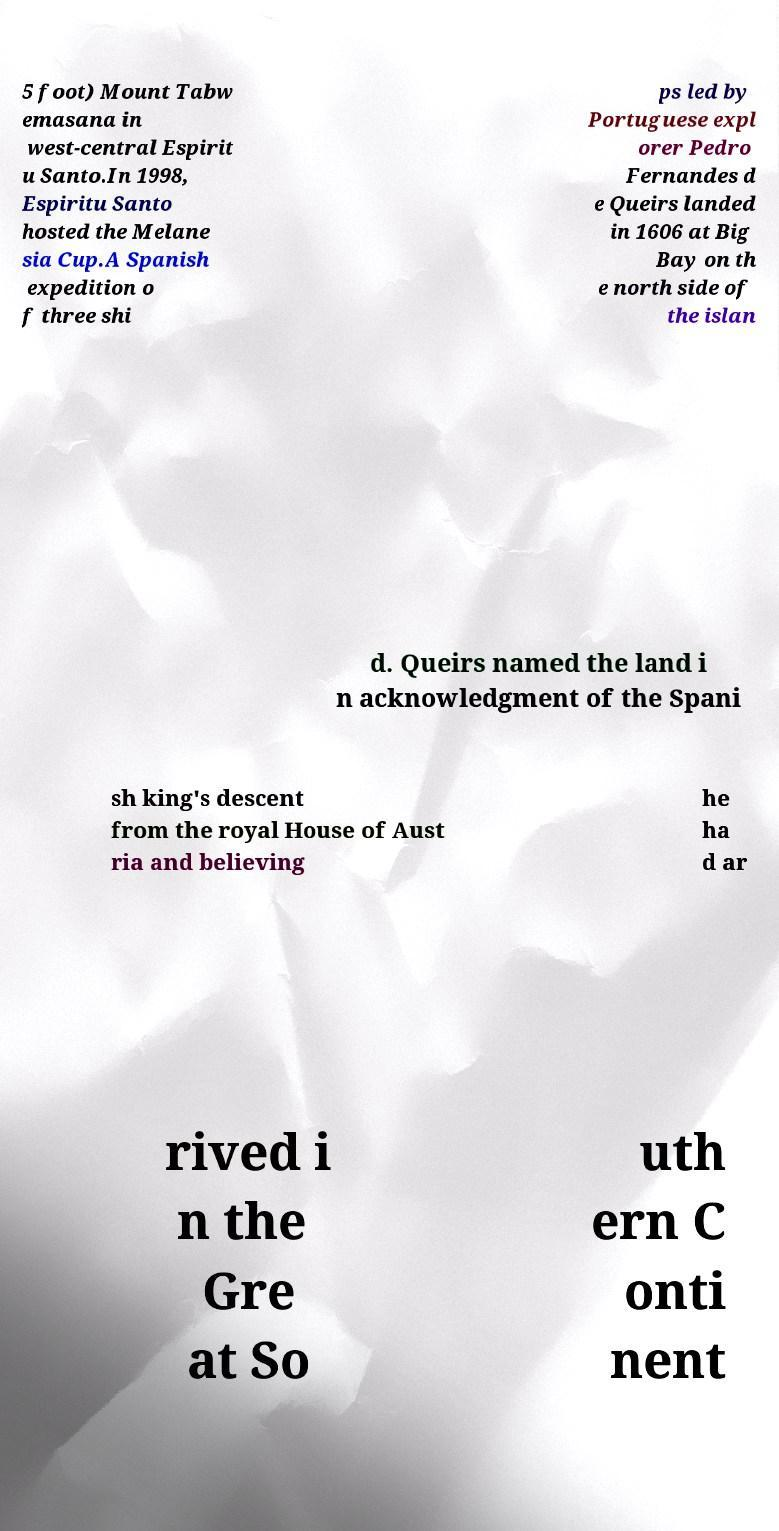Could you assist in decoding the text presented in this image and type it out clearly? 5 foot) Mount Tabw emasana in west-central Espirit u Santo.In 1998, Espiritu Santo hosted the Melane sia Cup.A Spanish expedition o f three shi ps led by Portuguese expl orer Pedro Fernandes d e Queirs landed in 1606 at Big Bay on th e north side of the islan d. Queirs named the land i n acknowledgment of the Spani sh king's descent from the royal House of Aust ria and believing he ha d ar rived i n the Gre at So uth ern C onti nent 